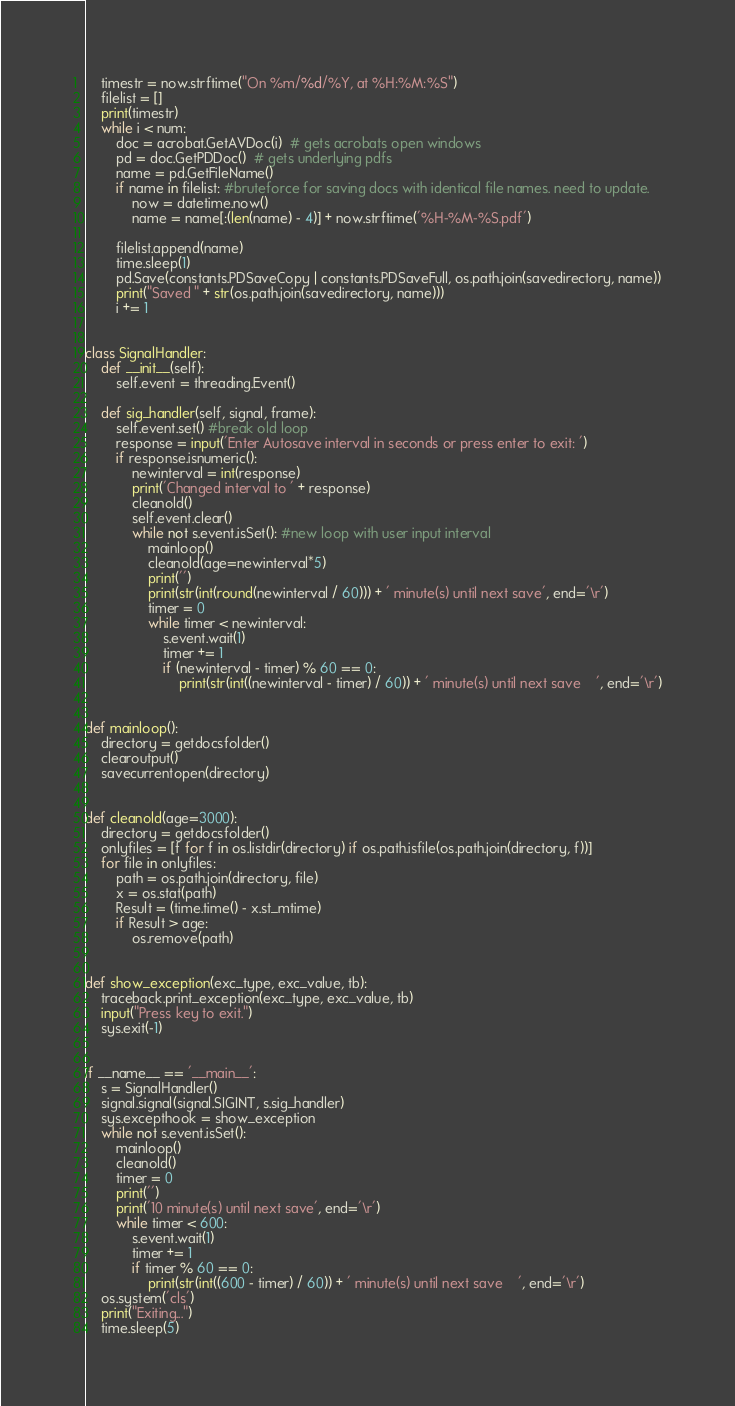<code> <loc_0><loc_0><loc_500><loc_500><_Python_>    timestr = now.strftime("On %m/%d/%Y, at %H:%M:%S")
    filelist = []
    print(timestr)
    while i < num:
        doc = acrobat.GetAVDoc(i)  # gets acrobats open windows
        pd = doc.GetPDDoc()  # gets underlying pdfs
        name = pd.GetFileName()
        if name in filelist: #bruteforce for saving docs with identical file names. need to update.
            now = datetime.now()
            name = name[:(len(name) - 4)] + now.strftime('%H-%M-%S.pdf')

        filelist.append(name)
        time.sleep(1)
        pd.Save(constants.PDSaveCopy | constants.PDSaveFull, os.path.join(savedirectory, name))
        print("Saved " + str(os.path.join(savedirectory, name)))
        i += 1


class SignalHandler:
    def __init__(self):
        self.event = threading.Event()

    def sig_handler(self, signal, frame):
        self.event.set() #break old loop
        response = input('Enter Autosave interval in seconds or press enter to exit: ')
        if response.isnumeric():
            newinterval = int(response)
            print('Changed interval to ' + response)
            cleanold()
            self.event.clear()
            while not s.event.isSet(): #new loop with user input interval
                mainloop()
                cleanold(age=newinterval*5)
                print('')
                print(str(int(round(newinterval / 60))) + ' minute(s) until next save', end='\r')
                timer = 0
                while timer < newinterval:
                    s.event.wait(1)
                    timer += 1
                    if (newinterval - timer) % 60 == 0:
                        print(str(int((newinterval - timer) / 60)) + ' minute(s) until next save    ', end='\r')


def mainloop():
    directory = getdocsfolder()
    clearoutput()
    savecurrentopen(directory)


def cleanold(age=3000):
    directory = getdocsfolder()
    onlyfiles = [f for f in os.listdir(directory) if os.path.isfile(os.path.join(directory, f))]
    for file in onlyfiles:
        path = os.path.join(directory, file)
        x = os.stat(path)
        Result = (time.time() - x.st_mtime)
        if Result > age:
            os.remove(path)


def show_exception(exc_type, exc_value, tb):
    traceback.print_exception(exc_type, exc_value, tb)
    input("Press key to exit.")
    sys.exit(-1)


if __name__ == '__main__':
    s = SignalHandler()
    signal.signal(signal.SIGINT, s.sig_handler)
    sys.excepthook = show_exception
    while not s.event.isSet():
        mainloop()
        cleanold()
        timer = 0
        print('')
        print('10 minute(s) until next save', end='\r')
        while timer < 600:
            s.event.wait(1)
            timer += 1
            if timer % 60 == 0:
                print(str(int((600 - timer) / 60)) + ' minute(s) until next save    ', end='\r')
    os.system('cls')
    print("Exiting...")
    time.sleep(5)
</code> 